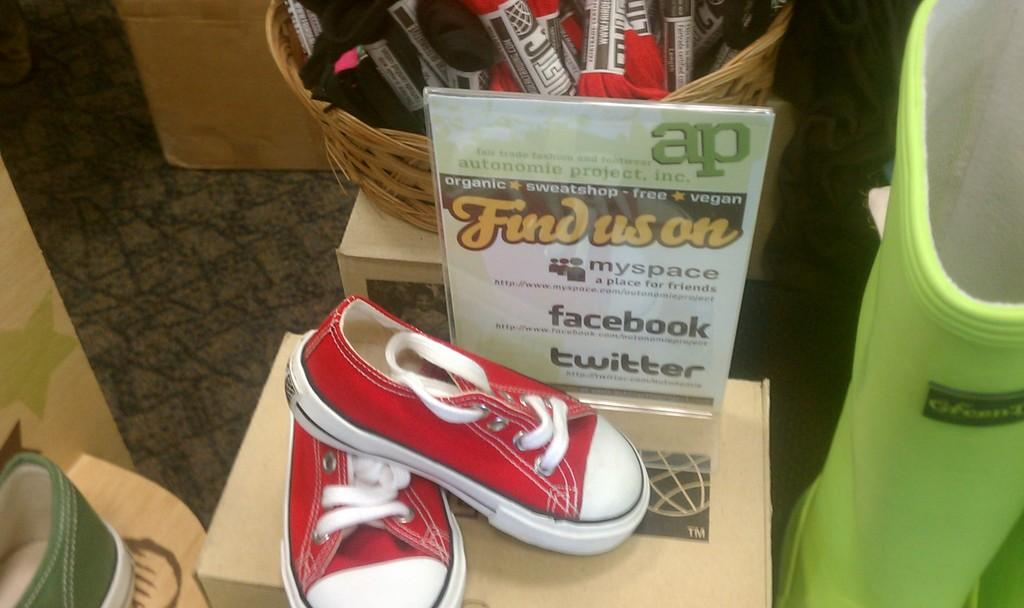What type of footwear is visible in the image? There are shoes in the image. What other objects can be seen in the image? There are boxes and a banner in the image. What piece of furniture is present in the image? There is a table in the image. What is placed on the table? There is a basket on the table. What is inside the basket? There are threads in the basket. How does the banner roll out in the image? The banner does not roll out in the image; it is stationary. What type of hose is used to clean the shoes in the image? There is no hose present in the image, and the shoes are not being cleaned. 